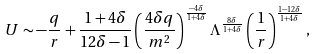<formula> <loc_0><loc_0><loc_500><loc_500>U \sim - \frac { q } { r } + \frac { 1 + 4 \delta } { 1 2 \delta - 1 } \left ( \frac { 4 \delta q } { m ^ { 2 } } \right ) ^ { \frac { - 4 \delta } { 1 + 4 \delta } } \Lambda ^ { \frac { 8 \delta } { 1 + 4 \delta } } \left ( \frac { 1 } { r } \right ) ^ { \frac { 1 - 1 2 \delta } { 1 + 4 \delta } } ,</formula> 